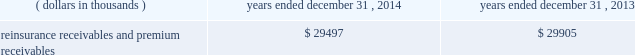Investments .
Fixed maturity and equity security investments available for sale , at market value , reflect unrealized appreciation and depreciation , as a result of temporary changes in market value during the period , in shareholders 2019 equity , net of income taxes in 201caccumulated other comprehensive income ( loss ) 201d in the consolidated balance sheets .
Fixed maturity and equity securities carried at fair value reflect fair value re- measurements as net realized capital gains and losses in the consolidated statements of operations and comprehensive income ( loss ) .
The company records changes in fair value for its fixed maturities available for sale , at market value through shareholders 2019 equity , net of taxes in accumulated other comprehensive income ( loss ) since cash flows from these investments will be primarily used to settle its reserve for losses and loss adjustment expense liabilities .
The company anticipates holding these investments for an extended period as the cash flow from interest and maturities will fund the projected payout of these liabilities .
Fixed maturities carried at fair value represent a portfolio of convertible bond securities , which have characteristics similar to equity securities and at times , designated foreign denominated fixed maturity securities , which will be used to settle loss and loss adjustment reserves in the same currency .
The company carries all of its equity securities at fair value except for mutual fund investments whose underlying investments are comprised of fixed maturity securities .
For equity securities , available for sale , at fair value , the company reflects changes in value as net realized capital gains and losses since these securities may be sold in the near term depending on financial market conditions .
Interest income on all fixed maturities and dividend income on all equity securities are included as part of net investment income in the consolidated statements of operations and comprehensive income ( loss ) .
Unrealized losses on fixed maturities , which are deemed other-than-temporary and related to the credit quality of a security , are charged to net income ( loss ) as net realized capital losses .
Short-term investments are stated at cost , which approximates market value .
Realized gains or losses on sales of investments are determined on the basis of identified cost .
For non- publicly traded securities , market prices are determined through the use of pricing models that evaluate securities relative to the u.s .
Treasury yield curve , taking into account the issue type , credit quality , and cash flow characteristics of each security .
For publicly traded securities , market value is based on quoted market prices or valuation models that use observable market inputs .
When a sector of the financial markets is inactive or illiquid , the company may use its own assumptions about future cash flows and risk-adjusted discount rates to determine fair value .
Retrospective adjustments are employed to recalculate the values of asset-backed securities .
Each acquisition lot is reviewed to recalculate the effective yield .
The recalculated effective yield is used to derive a book value as if the new yield were applied at the time of acquisition .
Outstanding principal factors from the time of acquisition to the adjustment date are used to calculate the prepayment history for all applicable securities .
Conditional prepayment rates , computed with life to date factor histories and weighted average maturities , are used to effect the calculation of projected and prepayments for pass-through security types .
Other invested assets include limited partnerships and rabbi trusts .
Limited partnerships are accounted for under the equity method of accounting , which can be recorded on a monthly or quarterly lag .
Uncollectible receivable balances .
The company provides reserves for uncollectible reinsurance recoverable and premium receivable balances based on management 2019s assessment of the collectability of the outstanding balances .
Such reserves are presented in the table below for the periods indicated. .

What was the change in the reinsurance receivables and premium receivables from 2014 to 2013 in thousands? 
Computations: (29497 - 29905)
Answer: -408.0. 